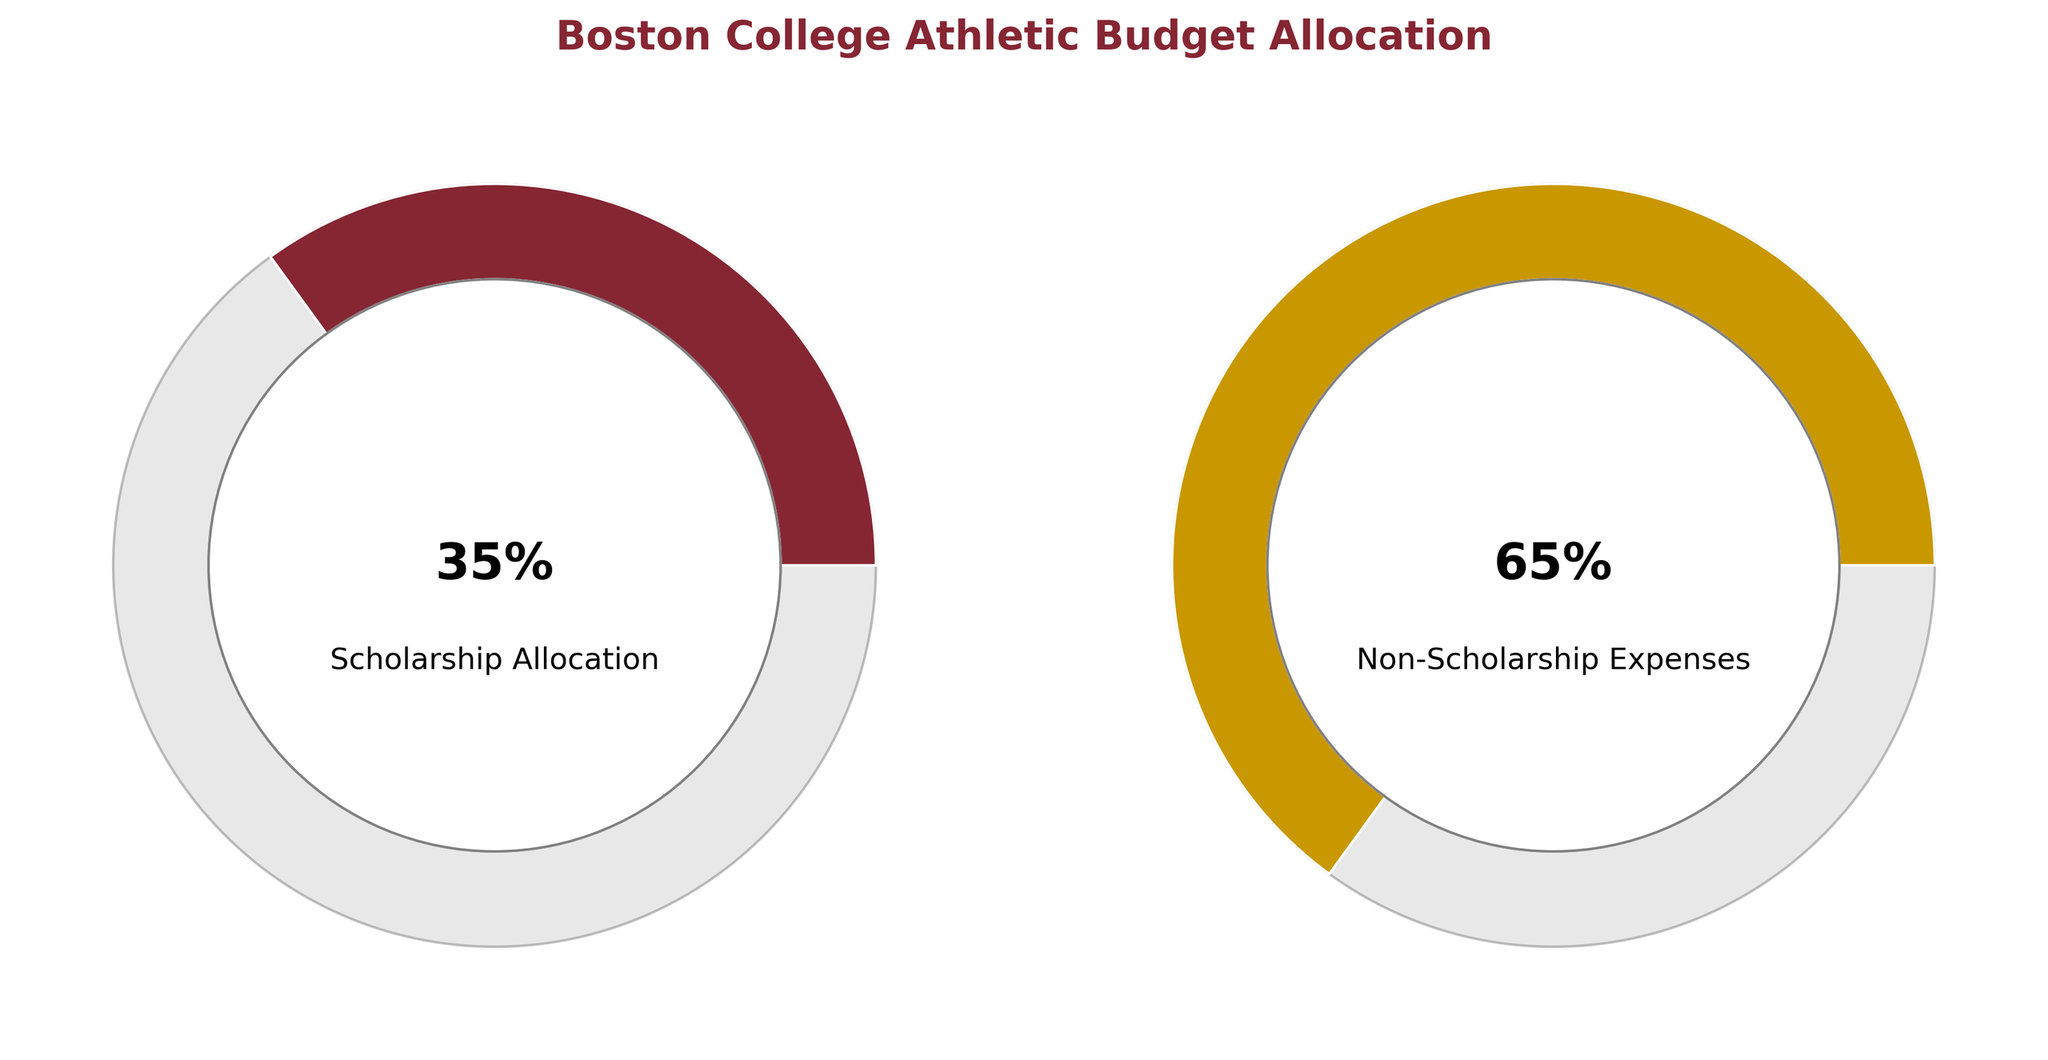What's the title of the figure? The title of the figure is located at the top and reads "Boston College Athletic Budget Allocation" in bold text.
Answer: Boston College Athletic Budget Allocation What is the percentage of the budget allocated to student-athlete scholarships? The gauge chart on the left side labeled "Scholarship Allocation" shows a value inside the inner circle. This value reads "35%", indicating 35% of the budget is allocated to student-athlete scholarships.
Answer: 35% What percentage of the athletic budget is allocated to non-scholarship expenses? The gauge chart on the right side labeled "Non-Scholarship Expenses" shows a value inside the inner circle. This value reads "65%", indicating 65% of the budget is allocated to non-scholarship expenses.
Answer: 65% Which category uses a larger portion of the budget? Comparing the values shown in the gauge charts, "Non-Scholarship Expenses" has a higher percentage (65%) compared to "Scholarship Allocation" (35%), indicating it uses a larger portion of the budget.
Answer: Non-Scholarship Expenses What is the total amount allocated to scholarships and non-scholarship expenses? The percentages in both categories can be summed to find the total allocation. 35% (scholarships) + 65% (non-scholarship expenses) = 100%.
Answer: 100% What color is used to represent the scholarship allocation? The gauge chart for "Scholarship Allocation" is filled in with a deep maroon color.
Answer: Maroon Are the colors used in the chart related to Boston College's school colors? The colors used in the gauge charts are deep maroon and gold. These colors are representative of Boston College's school colors.
Answer: Yes How do the gauge charts visually differentiate between the two categories? Each gauge chart represents a different category with its respective color. The inner circle provides the percentage allocation, and the text below the inner circle labels the category. The distribution of the color on the outer ring visually indicates the percentage.
Answer: Different colors and labels What is the difference in the percentage allocations between the two categories? To find the difference between the "Scholarship Allocation" and "Non-Scholarship Expenses," subtract the smaller percentage from the larger one. 65% (non-scholarship expenses) - 35% (scholarships) = 30%.
Answer: 30% What does the 0-100 range represent in the gauge charts? The 0-100 range in the gauge charts represents the total possible percentage allocation of the budget, indicating that the values can range from 0% to 100%.
Answer: Total budget percentage range 